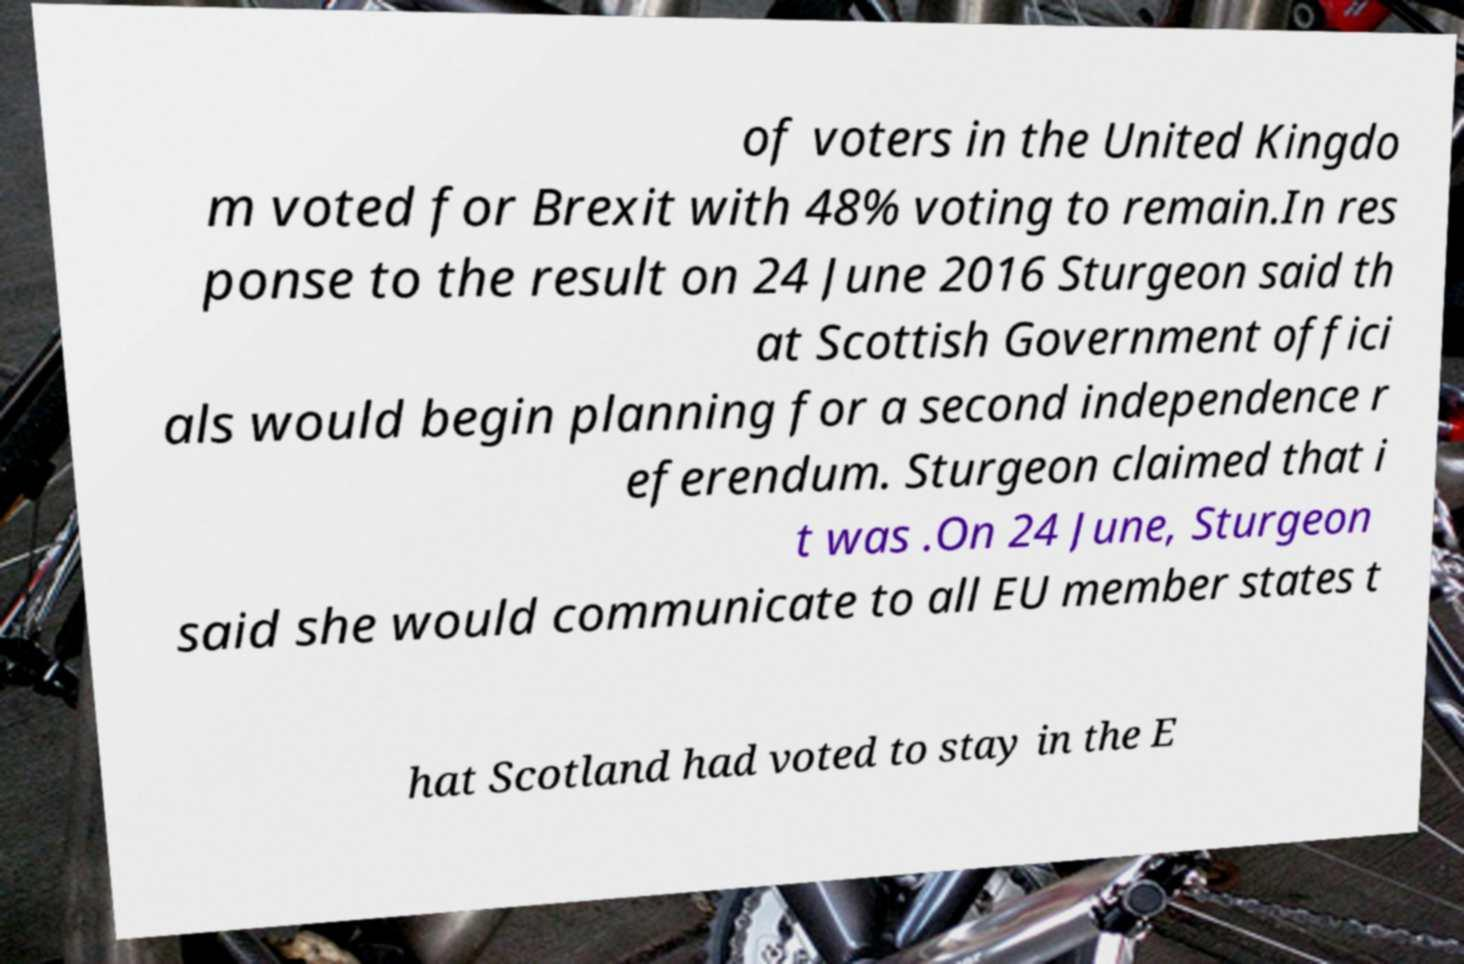I need the written content from this picture converted into text. Can you do that? of voters in the United Kingdo m voted for Brexit with 48% voting to remain.In res ponse to the result on 24 June 2016 Sturgeon said th at Scottish Government offici als would begin planning for a second independence r eferendum. Sturgeon claimed that i t was .On 24 June, Sturgeon said she would communicate to all EU member states t hat Scotland had voted to stay in the E 